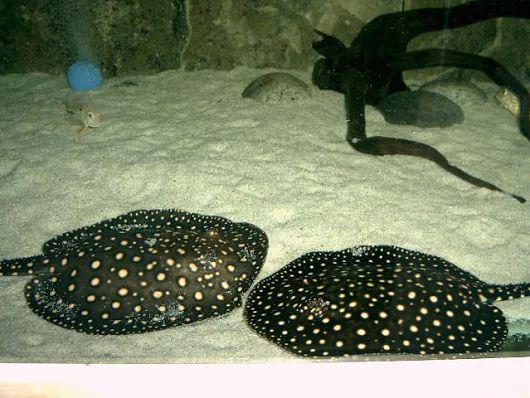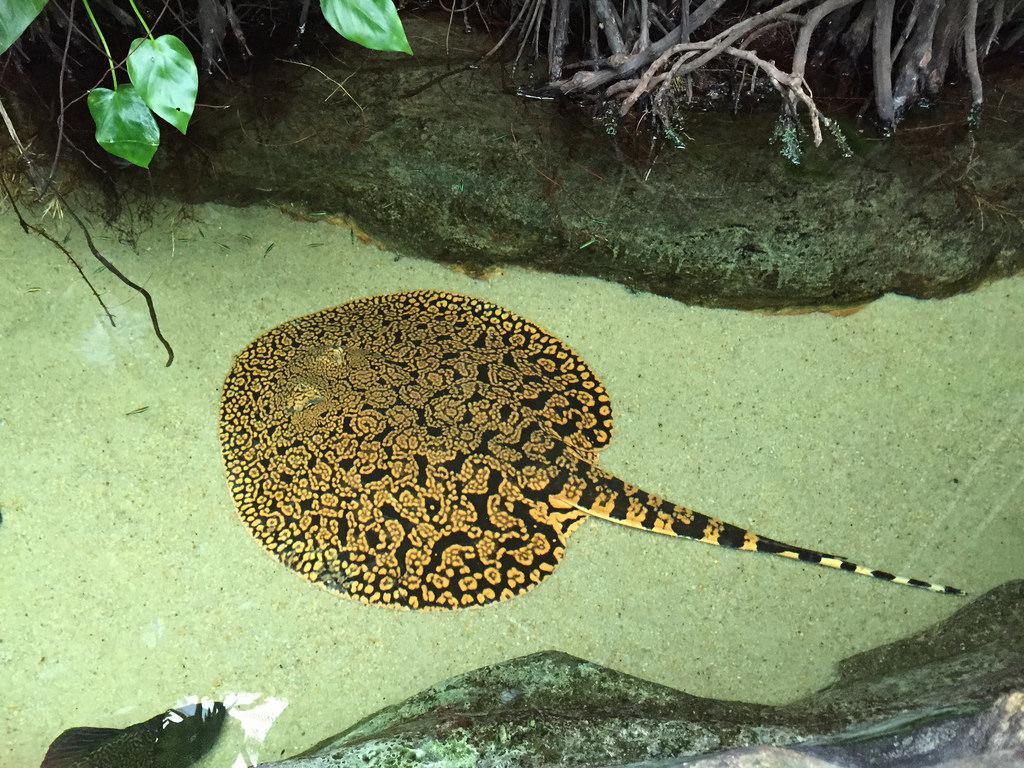The first image is the image on the left, the second image is the image on the right. For the images shown, is this caption "There are exactly three stingrays." true? Answer yes or no. Yes. 